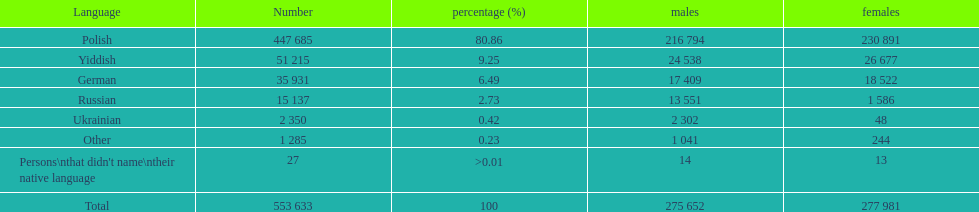What is the total number of speakers for all languages displayed on the table? 553 633. 